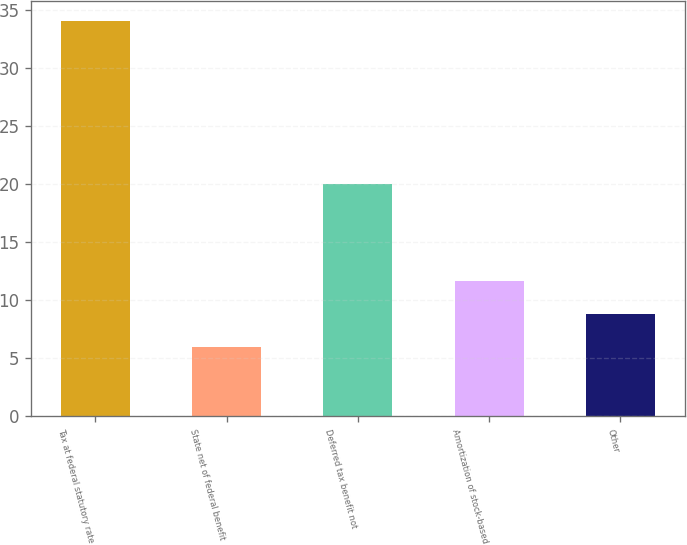<chart> <loc_0><loc_0><loc_500><loc_500><bar_chart><fcel>Tax at federal statutory rate<fcel>State net of federal benefit<fcel>Deferred tax benefit not<fcel>Amortization of stock-based<fcel>Other<nl><fcel>34<fcel>6<fcel>20<fcel>11.65<fcel>8.85<nl></chart> 